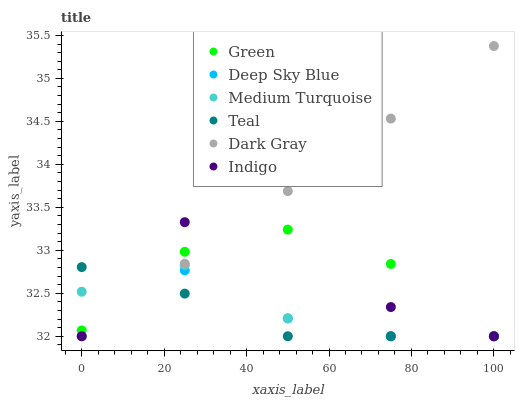Does Teal have the minimum area under the curve?
Answer yes or no. Yes. Does Dark Gray have the maximum area under the curve?
Answer yes or no. Yes. Does Medium Turquoise have the minimum area under the curve?
Answer yes or no. No. Does Medium Turquoise have the maximum area under the curve?
Answer yes or no. No. Is Dark Gray the smoothest?
Answer yes or no. Yes. Is Indigo the roughest?
Answer yes or no. Yes. Is Medium Turquoise the smoothest?
Answer yes or no. No. Is Medium Turquoise the roughest?
Answer yes or no. No. Does Indigo have the lowest value?
Answer yes or no. Yes. Does Dark Gray have the highest value?
Answer yes or no. Yes. Does Medium Turquoise have the highest value?
Answer yes or no. No. Does Teal intersect Green?
Answer yes or no. Yes. Is Teal less than Green?
Answer yes or no. No. Is Teal greater than Green?
Answer yes or no. No. 